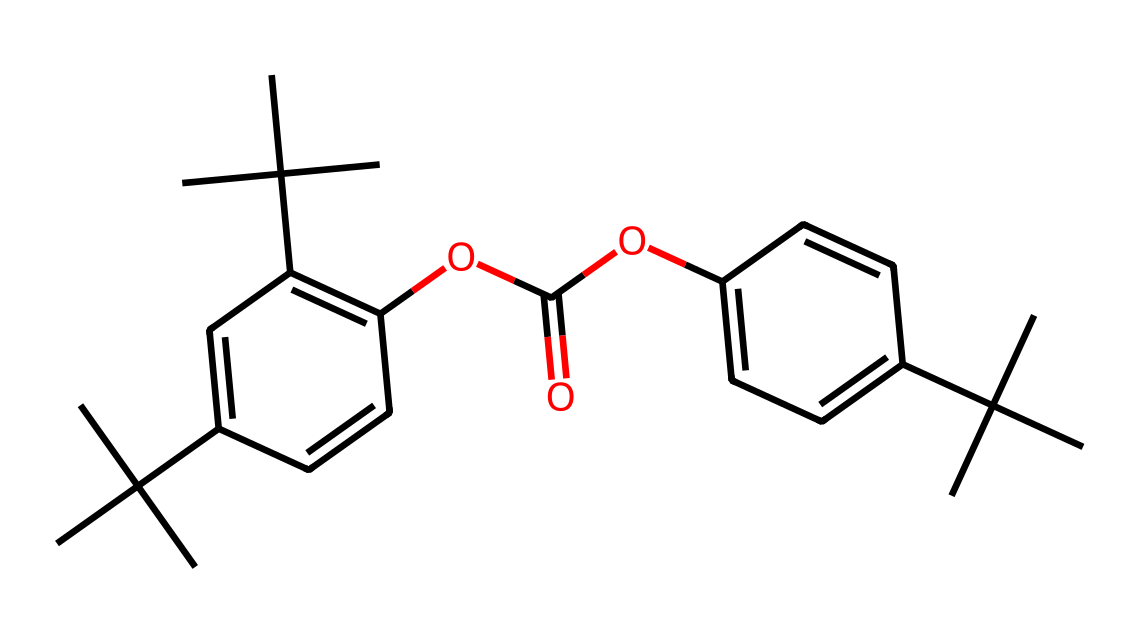What is the molecular formula derived from this structure? To determine the molecular formula, count the number of carbon (C), hydrogen (H), and oxygen (O) atoms in the SMILES representation. In this case, there are 26 carbon atoms, 38 hydrogen atoms, and 4 oxygen atoms, leading to the formula C26H38O4.
Answer: C26H38O4 How many rings are present in this molecule? Analyze the structure to identify cyclic components. This particular chemical structure has two aromatic rings (seen in the C1 and C2 cyclic components).
Answer: 2 What functional groups are present in this compound? Look for distinct features in the SMILES representation that denote functional groups. Here, there are ester groups indicated by the -OC(=O)- part, resulting in a total of two ester groups.
Answer: ester Is this compound saturated or unsaturated? Assess the presence of double bonds in the chemical structure. The structure shows double bonds, particularly within the aromatic rings indicating that it is not completely saturated.
Answer: unsaturated What is the significance of the branching in this hydrocarbon? Evaluate the overall structure and branching patterns. The multiple branching with tert-butyl groups contributes to lower density and potentially affects the physical properties like melting point and rigidity of the material.
Answer: affects physical properties 